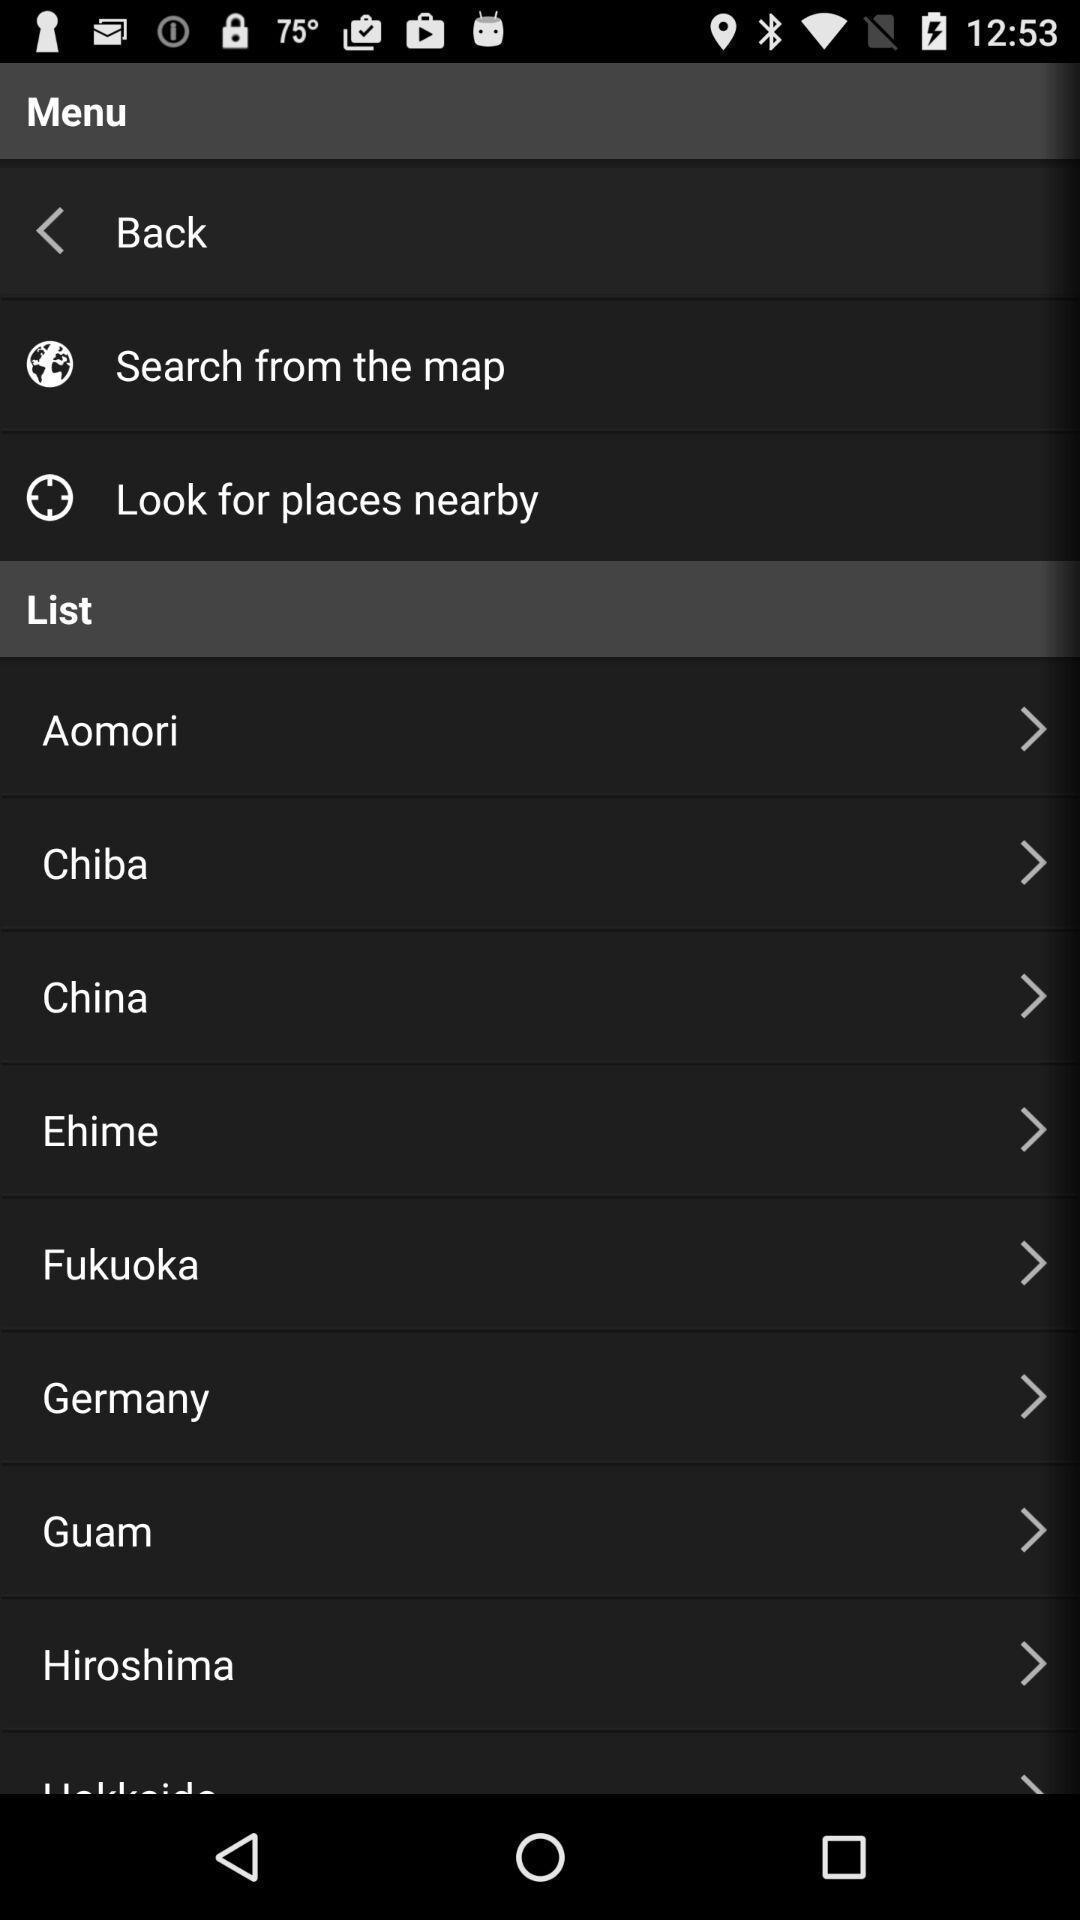Describe the content in this image. Screen page displaying various places. 